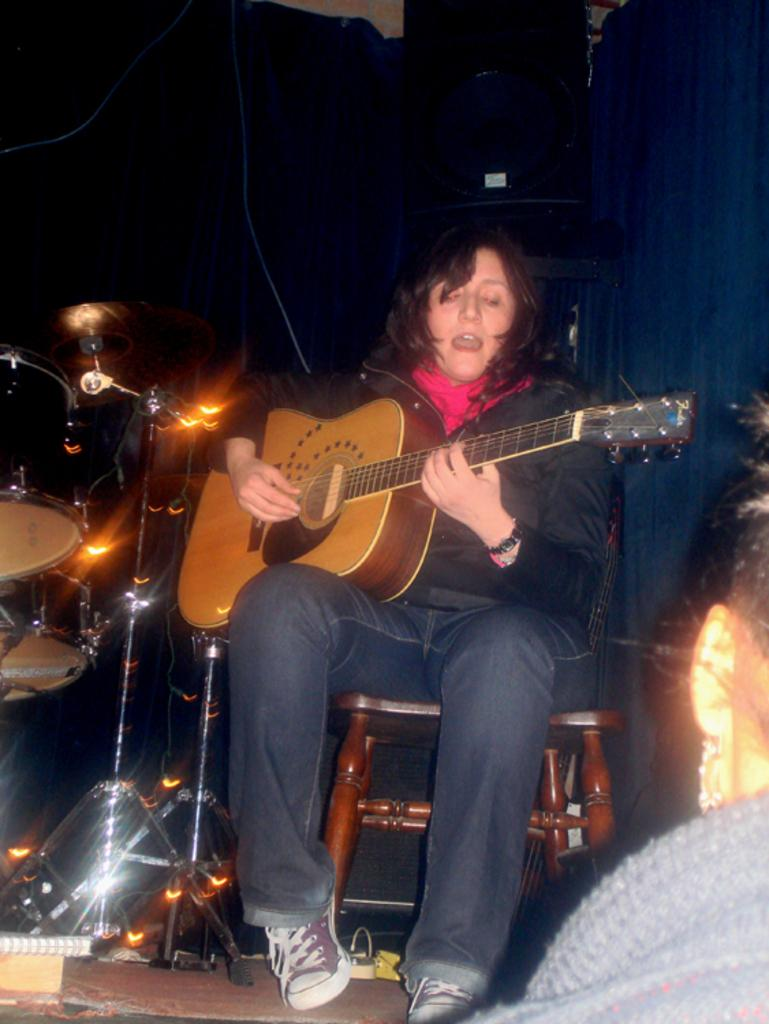What is the overall color scheme of the image? The background of the image is dark. What musical instruments are present in the image? There are drums in the image. What is the woman in the image doing? The woman is sitting on a chair, playing a guitar, and singing. What grade did the woman receive for her performance in the image? There is no indication of a performance or grade in the image; it simply shows a woman playing a guitar and singing. 